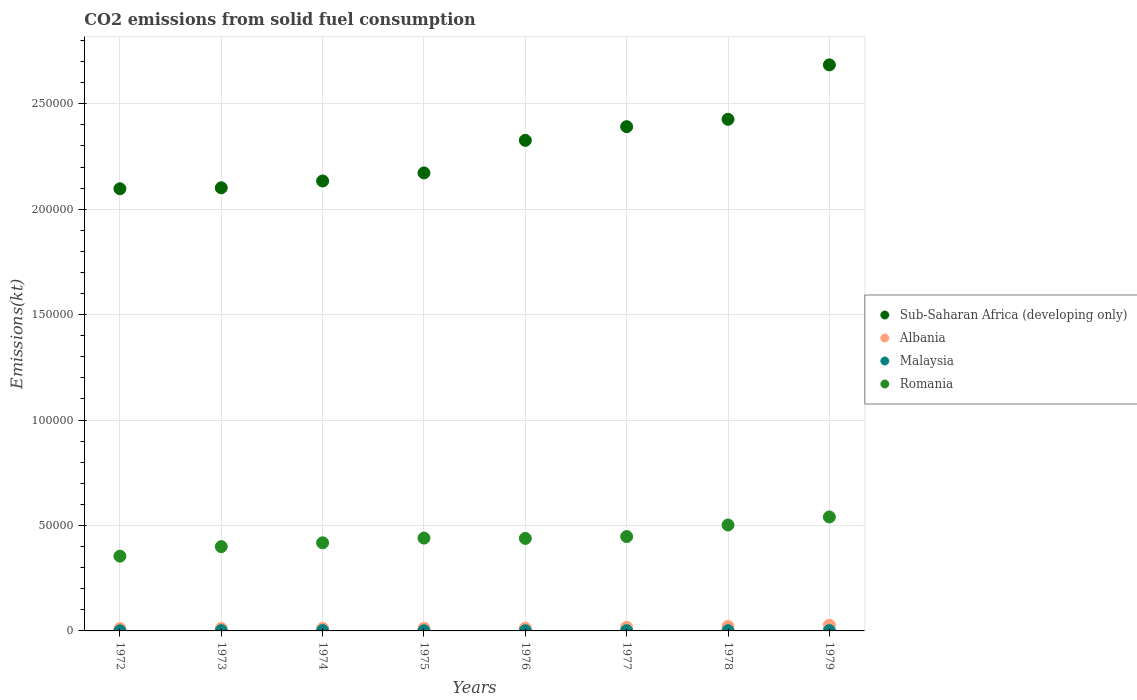What is the amount of CO2 emitted in Malaysia in 1976?
Your answer should be compact. 95.34. Across all years, what is the maximum amount of CO2 emitted in Malaysia?
Offer a very short reply. 161.35. Across all years, what is the minimum amount of CO2 emitted in Romania?
Provide a succinct answer. 3.55e+04. In which year was the amount of CO2 emitted in Malaysia maximum?
Offer a terse response. 1974. In which year was the amount of CO2 emitted in Romania minimum?
Offer a terse response. 1972. What is the total amount of CO2 emitted in Sub-Saharan Africa (developing only) in the graph?
Give a very brief answer. 1.83e+06. What is the difference between the amount of CO2 emitted in Malaysia in 1973 and that in 1979?
Your answer should be compact. -7.33. What is the difference between the amount of CO2 emitted in Sub-Saharan Africa (developing only) in 1973 and the amount of CO2 emitted in Albania in 1975?
Make the answer very short. 2.09e+05. What is the average amount of CO2 emitted in Malaysia per year?
Offer a terse response. 104.05. In the year 1975, what is the difference between the amount of CO2 emitted in Sub-Saharan Africa (developing only) and amount of CO2 emitted in Albania?
Your answer should be compact. 2.16e+05. In how many years, is the amount of CO2 emitted in Sub-Saharan Africa (developing only) greater than 40000 kt?
Keep it short and to the point. 8. What is the ratio of the amount of CO2 emitted in Malaysia in 1976 to that in 1977?
Give a very brief answer. 0.81. Is the amount of CO2 emitted in Sub-Saharan Africa (developing only) in 1973 less than that in 1975?
Offer a very short reply. Yes. Is the difference between the amount of CO2 emitted in Sub-Saharan Africa (developing only) in 1973 and 1974 greater than the difference between the amount of CO2 emitted in Albania in 1973 and 1974?
Provide a succinct answer. No. What is the difference between the highest and the second highest amount of CO2 emitted in Sub-Saharan Africa (developing only)?
Provide a short and direct response. 2.58e+04. What is the difference between the highest and the lowest amount of CO2 emitted in Sub-Saharan Africa (developing only)?
Keep it short and to the point. 5.87e+04. Is the sum of the amount of CO2 emitted in Albania in 1972 and 1978 greater than the maximum amount of CO2 emitted in Romania across all years?
Your answer should be very brief. No. Is the amount of CO2 emitted in Sub-Saharan Africa (developing only) strictly less than the amount of CO2 emitted in Albania over the years?
Provide a short and direct response. No. How many years are there in the graph?
Offer a terse response. 8. What is the difference between two consecutive major ticks on the Y-axis?
Offer a very short reply. 5.00e+04. Does the graph contain any zero values?
Give a very brief answer. No. Does the graph contain grids?
Your response must be concise. Yes. Where does the legend appear in the graph?
Make the answer very short. Center right. How many legend labels are there?
Give a very brief answer. 4. What is the title of the graph?
Give a very brief answer. CO2 emissions from solid fuel consumption. What is the label or title of the Y-axis?
Your answer should be very brief. Emissions(kt). What is the Emissions(kt) in Sub-Saharan Africa (developing only) in 1972?
Your answer should be very brief. 2.10e+05. What is the Emissions(kt) of Albania in 1972?
Your response must be concise. 1081.77. What is the Emissions(kt) in Malaysia in 1972?
Ensure brevity in your answer.  33. What is the Emissions(kt) of Romania in 1972?
Give a very brief answer. 3.55e+04. What is the Emissions(kt) of Sub-Saharan Africa (developing only) in 1973?
Give a very brief answer. 2.10e+05. What is the Emissions(kt) of Albania in 1973?
Your answer should be compact. 1169.77. What is the Emissions(kt) in Malaysia in 1973?
Provide a short and direct response. 128.34. What is the Emissions(kt) in Romania in 1973?
Offer a very short reply. 4.00e+04. What is the Emissions(kt) of Sub-Saharan Africa (developing only) in 1974?
Ensure brevity in your answer.  2.13e+05. What is the Emissions(kt) of Albania in 1974?
Your answer should be compact. 1210.11. What is the Emissions(kt) of Malaysia in 1974?
Offer a terse response. 161.35. What is the Emissions(kt) in Romania in 1974?
Your answer should be very brief. 4.18e+04. What is the Emissions(kt) of Sub-Saharan Africa (developing only) in 1975?
Give a very brief answer. 2.17e+05. What is the Emissions(kt) of Albania in 1975?
Make the answer very short. 1261.45. What is the Emissions(kt) of Malaysia in 1975?
Offer a very short reply. 69.67. What is the Emissions(kt) in Romania in 1975?
Your answer should be compact. 4.40e+04. What is the Emissions(kt) in Sub-Saharan Africa (developing only) in 1976?
Ensure brevity in your answer.  2.33e+05. What is the Emissions(kt) in Albania in 1976?
Your answer should be very brief. 1272.45. What is the Emissions(kt) in Malaysia in 1976?
Your answer should be compact. 95.34. What is the Emissions(kt) of Romania in 1976?
Your response must be concise. 4.39e+04. What is the Emissions(kt) in Sub-Saharan Africa (developing only) in 1977?
Ensure brevity in your answer.  2.39e+05. What is the Emissions(kt) in Albania in 1977?
Your answer should be very brief. 1701.49. What is the Emissions(kt) in Malaysia in 1977?
Make the answer very short. 117.34. What is the Emissions(kt) in Romania in 1977?
Provide a succinct answer. 4.47e+04. What is the Emissions(kt) in Sub-Saharan Africa (developing only) in 1978?
Provide a short and direct response. 2.43e+05. What is the Emissions(kt) of Albania in 1978?
Your answer should be very brief. 2126.86. What is the Emissions(kt) of Malaysia in 1978?
Your response must be concise. 91.67. What is the Emissions(kt) in Romania in 1978?
Your answer should be very brief. 5.02e+04. What is the Emissions(kt) in Sub-Saharan Africa (developing only) in 1979?
Your answer should be compact. 2.68e+05. What is the Emissions(kt) of Albania in 1979?
Your answer should be very brief. 2684.24. What is the Emissions(kt) in Malaysia in 1979?
Offer a terse response. 135.68. What is the Emissions(kt) in Romania in 1979?
Your answer should be compact. 5.40e+04. Across all years, what is the maximum Emissions(kt) in Sub-Saharan Africa (developing only)?
Offer a very short reply. 2.68e+05. Across all years, what is the maximum Emissions(kt) of Albania?
Make the answer very short. 2684.24. Across all years, what is the maximum Emissions(kt) in Malaysia?
Ensure brevity in your answer.  161.35. Across all years, what is the maximum Emissions(kt) in Romania?
Give a very brief answer. 5.40e+04. Across all years, what is the minimum Emissions(kt) of Sub-Saharan Africa (developing only)?
Give a very brief answer. 2.10e+05. Across all years, what is the minimum Emissions(kt) in Albania?
Offer a very short reply. 1081.77. Across all years, what is the minimum Emissions(kt) of Malaysia?
Offer a terse response. 33. Across all years, what is the minimum Emissions(kt) of Romania?
Your answer should be very brief. 3.55e+04. What is the total Emissions(kt) of Sub-Saharan Africa (developing only) in the graph?
Your response must be concise. 1.83e+06. What is the total Emissions(kt) of Albania in the graph?
Ensure brevity in your answer.  1.25e+04. What is the total Emissions(kt) in Malaysia in the graph?
Provide a short and direct response. 832.41. What is the total Emissions(kt) of Romania in the graph?
Ensure brevity in your answer.  3.54e+05. What is the difference between the Emissions(kt) of Sub-Saharan Africa (developing only) in 1972 and that in 1973?
Give a very brief answer. -464.89. What is the difference between the Emissions(kt) of Albania in 1972 and that in 1973?
Provide a short and direct response. -88.01. What is the difference between the Emissions(kt) of Malaysia in 1972 and that in 1973?
Keep it short and to the point. -95.34. What is the difference between the Emissions(kt) of Romania in 1972 and that in 1973?
Your answer should be very brief. -4517.74. What is the difference between the Emissions(kt) of Sub-Saharan Africa (developing only) in 1972 and that in 1974?
Keep it short and to the point. -3683.84. What is the difference between the Emissions(kt) in Albania in 1972 and that in 1974?
Give a very brief answer. -128.34. What is the difference between the Emissions(kt) of Malaysia in 1972 and that in 1974?
Provide a succinct answer. -128.34. What is the difference between the Emissions(kt) of Romania in 1972 and that in 1974?
Make the answer very short. -6340.24. What is the difference between the Emissions(kt) of Sub-Saharan Africa (developing only) in 1972 and that in 1975?
Provide a succinct answer. -7510.91. What is the difference between the Emissions(kt) of Albania in 1972 and that in 1975?
Offer a very short reply. -179.68. What is the difference between the Emissions(kt) of Malaysia in 1972 and that in 1975?
Make the answer very short. -36.67. What is the difference between the Emissions(kt) of Romania in 1972 and that in 1975?
Your answer should be very brief. -8573.45. What is the difference between the Emissions(kt) in Sub-Saharan Africa (developing only) in 1972 and that in 1976?
Your answer should be compact. -2.30e+04. What is the difference between the Emissions(kt) of Albania in 1972 and that in 1976?
Offer a terse response. -190.68. What is the difference between the Emissions(kt) of Malaysia in 1972 and that in 1976?
Provide a short and direct response. -62.34. What is the difference between the Emissions(kt) in Romania in 1972 and that in 1976?
Your answer should be very brief. -8419.43. What is the difference between the Emissions(kt) of Sub-Saharan Africa (developing only) in 1972 and that in 1977?
Give a very brief answer. -2.94e+04. What is the difference between the Emissions(kt) of Albania in 1972 and that in 1977?
Ensure brevity in your answer.  -619.72. What is the difference between the Emissions(kt) of Malaysia in 1972 and that in 1977?
Your answer should be very brief. -84.34. What is the difference between the Emissions(kt) of Romania in 1972 and that in 1977?
Ensure brevity in your answer.  -9295.84. What is the difference between the Emissions(kt) of Sub-Saharan Africa (developing only) in 1972 and that in 1978?
Offer a very short reply. -3.29e+04. What is the difference between the Emissions(kt) in Albania in 1972 and that in 1978?
Your answer should be very brief. -1045.1. What is the difference between the Emissions(kt) of Malaysia in 1972 and that in 1978?
Ensure brevity in your answer.  -58.67. What is the difference between the Emissions(kt) in Romania in 1972 and that in 1978?
Provide a short and direct response. -1.48e+04. What is the difference between the Emissions(kt) of Sub-Saharan Africa (developing only) in 1972 and that in 1979?
Keep it short and to the point. -5.87e+04. What is the difference between the Emissions(kt) of Albania in 1972 and that in 1979?
Offer a very short reply. -1602.48. What is the difference between the Emissions(kt) in Malaysia in 1972 and that in 1979?
Offer a terse response. -102.68. What is the difference between the Emissions(kt) of Romania in 1972 and that in 1979?
Your answer should be compact. -1.86e+04. What is the difference between the Emissions(kt) of Sub-Saharan Africa (developing only) in 1973 and that in 1974?
Ensure brevity in your answer.  -3218.95. What is the difference between the Emissions(kt) in Albania in 1973 and that in 1974?
Offer a terse response. -40.34. What is the difference between the Emissions(kt) in Malaysia in 1973 and that in 1974?
Provide a short and direct response. -33. What is the difference between the Emissions(kt) of Romania in 1973 and that in 1974?
Your response must be concise. -1822.5. What is the difference between the Emissions(kt) of Sub-Saharan Africa (developing only) in 1973 and that in 1975?
Offer a very short reply. -7046.02. What is the difference between the Emissions(kt) of Albania in 1973 and that in 1975?
Ensure brevity in your answer.  -91.67. What is the difference between the Emissions(kt) in Malaysia in 1973 and that in 1975?
Keep it short and to the point. 58.67. What is the difference between the Emissions(kt) in Romania in 1973 and that in 1975?
Make the answer very short. -4055.7. What is the difference between the Emissions(kt) in Sub-Saharan Africa (developing only) in 1973 and that in 1976?
Keep it short and to the point. -2.25e+04. What is the difference between the Emissions(kt) of Albania in 1973 and that in 1976?
Your answer should be very brief. -102.68. What is the difference between the Emissions(kt) in Malaysia in 1973 and that in 1976?
Ensure brevity in your answer.  33. What is the difference between the Emissions(kt) in Romania in 1973 and that in 1976?
Provide a short and direct response. -3901.69. What is the difference between the Emissions(kt) in Sub-Saharan Africa (developing only) in 1973 and that in 1977?
Make the answer very short. -2.90e+04. What is the difference between the Emissions(kt) of Albania in 1973 and that in 1977?
Offer a very short reply. -531.72. What is the difference between the Emissions(kt) of Malaysia in 1973 and that in 1977?
Provide a succinct answer. 11. What is the difference between the Emissions(kt) in Romania in 1973 and that in 1977?
Your answer should be compact. -4778.1. What is the difference between the Emissions(kt) of Sub-Saharan Africa (developing only) in 1973 and that in 1978?
Your answer should be very brief. -3.25e+04. What is the difference between the Emissions(kt) of Albania in 1973 and that in 1978?
Give a very brief answer. -957.09. What is the difference between the Emissions(kt) of Malaysia in 1973 and that in 1978?
Ensure brevity in your answer.  36.67. What is the difference between the Emissions(kt) of Romania in 1973 and that in 1978?
Give a very brief answer. -1.03e+04. What is the difference between the Emissions(kt) in Sub-Saharan Africa (developing only) in 1973 and that in 1979?
Give a very brief answer. -5.83e+04. What is the difference between the Emissions(kt) in Albania in 1973 and that in 1979?
Offer a very short reply. -1514.47. What is the difference between the Emissions(kt) of Malaysia in 1973 and that in 1979?
Give a very brief answer. -7.33. What is the difference between the Emissions(kt) of Romania in 1973 and that in 1979?
Offer a terse response. -1.41e+04. What is the difference between the Emissions(kt) of Sub-Saharan Africa (developing only) in 1974 and that in 1975?
Your answer should be compact. -3827.07. What is the difference between the Emissions(kt) in Albania in 1974 and that in 1975?
Make the answer very short. -51.34. What is the difference between the Emissions(kt) in Malaysia in 1974 and that in 1975?
Give a very brief answer. 91.67. What is the difference between the Emissions(kt) in Romania in 1974 and that in 1975?
Keep it short and to the point. -2233.2. What is the difference between the Emissions(kt) of Sub-Saharan Africa (developing only) in 1974 and that in 1976?
Keep it short and to the point. -1.93e+04. What is the difference between the Emissions(kt) of Albania in 1974 and that in 1976?
Provide a short and direct response. -62.34. What is the difference between the Emissions(kt) of Malaysia in 1974 and that in 1976?
Your response must be concise. 66.01. What is the difference between the Emissions(kt) of Romania in 1974 and that in 1976?
Offer a very short reply. -2079.19. What is the difference between the Emissions(kt) of Sub-Saharan Africa (developing only) in 1974 and that in 1977?
Provide a short and direct response. -2.58e+04. What is the difference between the Emissions(kt) in Albania in 1974 and that in 1977?
Provide a short and direct response. -491.38. What is the difference between the Emissions(kt) of Malaysia in 1974 and that in 1977?
Ensure brevity in your answer.  44. What is the difference between the Emissions(kt) in Romania in 1974 and that in 1977?
Your answer should be compact. -2955.6. What is the difference between the Emissions(kt) of Sub-Saharan Africa (developing only) in 1974 and that in 1978?
Provide a succinct answer. -2.93e+04. What is the difference between the Emissions(kt) of Albania in 1974 and that in 1978?
Offer a very short reply. -916.75. What is the difference between the Emissions(kt) of Malaysia in 1974 and that in 1978?
Keep it short and to the point. 69.67. What is the difference between the Emissions(kt) in Romania in 1974 and that in 1978?
Provide a short and direct response. -8441.43. What is the difference between the Emissions(kt) in Sub-Saharan Africa (developing only) in 1974 and that in 1979?
Ensure brevity in your answer.  -5.51e+04. What is the difference between the Emissions(kt) in Albania in 1974 and that in 1979?
Your answer should be compact. -1474.13. What is the difference between the Emissions(kt) of Malaysia in 1974 and that in 1979?
Offer a terse response. 25.67. What is the difference between the Emissions(kt) of Romania in 1974 and that in 1979?
Offer a terse response. -1.23e+04. What is the difference between the Emissions(kt) in Sub-Saharan Africa (developing only) in 1975 and that in 1976?
Your response must be concise. -1.54e+04. What is the difference between the Emissions(kt) in Albania in 1975 and that in 1976?
Ensure brevity in your answer.  -11. What is the difference between the Emissions(kt) in Malaysia in 1975 and that in 1976?
Make the answer very short. -25.67. What is the difference between the Emissions(kt) of Romania in 1975 and that in 1976?
Keep it short and to the point. 154.01. What is the difference between the Emissions(kt) of Sub-Saharan Africa (developing only) in 1975 and that in 1977?
Make the answer very short. -2.19e+04. What is the difference between the Emissions(kt) in Albania in 1975 and that in 1977?
Provide a succinct answer. -440.04. What is the difference between the Emissions(kt) of Malaysia in 1975 and that in 1977?
Your response must be concise. -47.67. What is the difference between the Emissions(kt) of Romania in 1975 and that in 1977?
Provide a short and direct response. -722.4. What is the difference between the Emissions(kt) of Sub-Saharan Africa (developing only) in 1975 and that in 1978?
Make the answer very short. -2.54e+04. What is the difference between the Emissions(kt) in Albania in 1975 and that in 1978?
Your response must be concise. -865.41. What is the difference between the Emissions(kt) in Malaysia in 1975 and that in 1978?
Give a very brief answer. -22. What is the difference between the Emissions(kt) of Romania in 1975 and that in 1978?
Offer a very short reply. -6208.23. What is the difference between the Emissions(kt) in Sub-Saharan Africa (developing only) in 1975 and that in 1979?
Offer a terse response. -5.12e+04. What is the difference between the Emissions(kt) in Albania in 1975 and that in 1979?
Provide a succinct answer. -1422.8. What is the difference between the Emissions(kt) of Malaysia in 1975 and that in 1979?
Your answer should be compact. -66.01. What is the difference between the Emissions(kt) in Romania in 1975 and that in 1979?
Your answer should be very brief. -1.00e+04. What is the difference between the Emissions(kt) of Sub-Saharan Africa (developing only) in 1976 and that in 1977?
Provide a short and direct response. -6484.05. What is the difference between the Emissions(kt) in Albania in 1976 and that in 1977?
Your response must be concise. -429.04. What is the difference between the Emissions(kt) of Malaysia in 1976 and that in 1977?
Keep it short and to the point. -22. What is the difference between the Emissions(kt) in Romania in 1976 and that in 1977?
Provide a short and direct response. -876.41. What is the difference between the Emissions(kt) in Sub-Saharan Africa (developing only) in 1976 and that in 1978?
Keep it short and to the point. -9984.11. What is the difference between the Emissions(kt) of Albania in 1976 and that in 1978?
Your answer should be very brief. -854.41. What is the difference between the Emissions(kt) of Malaysia in 1976 and that in 1978?
Ensure brevity in your answer.  3.67. What is the difference between the Emissions(kt) of Romania in 1976 and that in 1978?
Provide a short and direct response. -6362.24. What is the difference between the Emissions(kt) of Sub-Saharan Africa (developing only) in 1976 and that in 1979?
Your response must be concise. -3.58e+04. What is the difference between the Emissions(kt) of Albania in 1976 and that in 1979?
Ensure brevity in your answer.  -1411.8. What is the difference between the Emissions(kt) of Malaysia in 1976 and that in 1979?
Your answer should be very brief. -40.34. What is the difference between the Emissions(kt) of Romania in 1976 and that in 1979?
Give a very brief answer. -1.02e+04. What is the difference between the Emissions(kt) of Sub-Saharan Africa (developing only) in 1977 and that in 1978?
Your response must be concise. -3500.06. What is the difference between the Emissions(kt) in Albania in 1977 and that in 1978?
Your answer should be very brief. -425.37. What is the difference between the Emissions(kt) in Malaysia in 1977 and that in 1978?
Your response must be concise. 25.67. What is the difference between the Emissions(kt) of Romania in 1977 and that in 1978?
Provide a short and direct response. -5485.83. What is the difference between the Emissions(kt) of Sub-Saharan Africa (developing only) in 1977 and that in 1979?
Your response must be concise. -2.93e+04. What is the difference between the Emissions(kt) in Albania in 1977 and that in 1979?
Ensure brevity in your answer.  -982.76. What is the difference between the Emissions(kt) of Malaysia in 1977 and that in 1979?
Offer a very short reply. -18.34. What is the difference between the Emissions(kt) in Romania in 1977 and that in 1979?
Your answer should be compact. -9295.84. What is the difference between the Emissions(kt) in Sub-Saharan Africa (developing only) in 1978 and that in 1979?
Give a very brief answer. -2.58e+04. What is the difference between the Emissions(kt) in Albania in 1978 and that in 1979?
Keep it short and to the point. -557.38. What is the difference between the Emissions(kt) in Malaysia in 1978 and that in 1979?
Provide a succinct answer. -44. What is the difference between the Emissions(kt) in Romania in 1978 and that in 1979?
Provide a short and direct response. -3810.01. What is the difference between the Emissions(kt) of Sub-Saharan Africa (developing only) in 1972 and the Emissions(kt) of Albania in 1973?
Your response must be concise. 2.09e+05. What is the difference between the Emissions(kt) in Sub-Saharan Africa (developing only) in 1972 and the Emissions(kt) in Malaysia in 1973?
Offer a very short reply. 2.10e+05. What is the difference between the Emissions(kt) of Sub-Saharan Africa (developing only) in 1972 and the Emissions(kt) of Romania in 1973?
Make the answer very short. 1.70e+05. What is the difference between the Emissions(kt) of Albania in 1972 and the Emissions(kt) of Malaysia in 1973?
Keep it short and to the point. 953.42. What is the difference between the Emissions(kt) of Albania in 1972 and the Emissions(kt) of Romania in 1973?
Keep it short and to the point. -3.89e+04. What is the difference between the Emissions(kt) of Malaysia in 1972 and the Emissions(kt) of Romania in 1973?
Make the answer very short. -3.99e+04. What is the difference between the Emissions(kt) in Sub-Saharan Africa (developing only) in 1972 and the Emissions(kt) in Albania in 1974?
Keep it short and to the point. 2.08e+05. What is the difference between the Emissions(kt) in Sub-Saharan Africa (developing only) in 1972 and the Emissions(kt) in Malaysia in 1974?
Give a very brief answer. 2.10e+05. What is the difference between the Emissions(kt) of Sub-Saharan Africa (developing only) in 1972 and the Emissions(kt) of Romania in 1974?
Your answer should be very brief. 1.68e+05. What is the difference between the Emissions(kt) of Albania in 1972 and the Emissions(kt) of Malaysia in 1974?
Give a very brief answer. 920.42. What is the difference between the Emissions(kt) of Albania in 1972 and the Emissions(kt) of Romania in 1974?
Give a very brief answer. -4.07e+04. What is the difference between the Emissions(kt) in Malaysia in 1972 and the Emissions(kt) in Romania in 1974?
Your answer should be very brief. -4.18e+04. What is the difference between the Emissions(kt) of Sub-Saharan Africa (developing only) in 1972 and the Emissions(kt) of Albania in 1975?
Your answer should be compact. 2.08e+05. What is the difference between the Emissions(kt) of Sub-Saharan Africa (developing only) in 1972 and the Emissions(kt) of Malaysia in 1975?
Ensure brevity in your answer.  2.10e+05. What is the difference between the Emissions(kt) of Sub-Saharan Africa (developing only) in 1972 and the Emissions(kt) of Romania in 1975?
Your response must be concise. 1.66e+05. What is the difference between the Emissions(kt) of Albania in 1972 and the Emissions(kt) of Malaysia in 1975?
Offer a terse response. 1012.09. What is the difference between the Emissions(kt) of Albania in 1972 and the Emissions(kt) of Romania in 1975?
Your answer should be very brief. -4.29e+04. What is the difference between the Emissions(kt) of Malaysia in 1972 and the Emissions(kt) of Romania in 1975?
Make the answer very short. -4.40e+04. What is the difference between the Emissions(kt) in Sub-Saharan Africa (developing only) in 1972 and the Emissions(kt) in Albania in 1976?
Your answer should be compact. 2.08e+05. What is the difference between the Emissions(kt) of Sub-Saharan Africa (developing only) in 1972 and the Emissions(kt) of Malaysia in 1976?
Offer a very short reply. 2.10e+05. What is the difference between the Emissions(kt) of Sub-Saharan Africa (developing only) in 1972 and the Emissions(kt) of Romania in 1976?
Make the answer very short. 1.66e+05. What is the difference between the Emissions(kt) in Albania in 1972 and the Emissions(kt) in Malaysia in 1976?
Give a very brief answer. 986.42. What is the difference between the Emissions(kt) of Albania in 1972 and the Emissions(kt) of Romania in 1976?
Offer a very short reply. -4.28e+04. What is the difference between the Emissions(kt) in Malaysia in 1972 and the Emissions(kt) in Romania in 1976?
Provide a short and direct response. -4.38e+04. What is the difference between the Emissions(kt) of Sub-Saharan Africa (developing only) in 1972 and the Emissions(kt) of Albania in 1977?
Keep it short and to the point. 2.08e+05. What is the difference between the Emissions(kt) in Sub-Saharan Africa (developing only) in 1972 and the Emissions(kt) in Malaysia in 1977?
Your response must be concise. 2.10e+05. What is the difference between the Emissions(kt) of Sub-Saharan Africa (developing only) in 1972 and the Emissions(kt) of Romania in 1977?
Offer a terse response. 1.65e+05. What is the difference between the Emissions(kt) in Albania in 1972 and the Emissions(kt) in Malaysia in 1977?
Make the answer very short. 964.42. What is the difference between the Emissions(kt) in Albania in 1972 and the Emissions(kt) in Romania in 1977?
Offer a very short reply. -4.37e+04. What is the difference between the Emissions(kt) in Malaysia in 1972 and the Emissions(kt) in Romania in 1977?
Your response must be concise. -4.47e+04. What is the difference between the Emissions(kt) in Sub-Saharan Africa (developing only) in 1972 and the Emissions(kt) in Albania in 1978?
Ensure brevity in your answer.  2.08e+05. What is the difference between the Emissions(kt) in Sub-Saharan Africa (developing only) in 1972 and the Emissions(kt) in Malaysia in 1978?
Keep it short and to the point. 2.10e+05. What is the difference between the Emissions(kt) in Sub-Saharan Africa (developing only) in 1972 and the Emissions(kt) in Romania in 1978?
Offer a very short reply. 1.59e+05. What is the difference between the Emissions(kt) in Albania in 1972 and the Emissions(kt) in Malaysia in 1978?
Offer a very short reply. 990.09. What is the difference between the Emissions(kt) of Albania in 1972 and the Emissions(kt) of Romania in 1978?
Provide a short and direct response. -4.92e+04. What is the difference between the Emissions(kt) of Malaysia in 1972 and the Emissions(kt) of Romania in 1978?
Make the answer very short. -5.02e+04. What is the difference between the Emissions(kt) in Sub-Saharan Africa (developing only) in 1972 and the Emissions(kt) in Albania in 1979?
Your response must be concise. 2.07e+05. What is the difference between the Emissions(kt) in Sub-Saharan Africa (developing only) in 1972 and the Emissions(kt) in Malaysia in 1979?
Your answer should be very brief. 2.10e+05. What is the difference between the Emissions(kt) of Sub-Saharan Africa (developing only) in 1972 and the Emissions(kt) of Romania in 1979?
Provide a short and direct response. 1.56e+05. What is the difference between the Emissions(kt) of Albania in 1972 and the Emissions(kt) of Malaysia in 1979?
Your response must be concise. 946.09. What is the difference between the Emissions(kt) of Albania in 1972 and the Emissions(kt) of Romania in 1979?
Offer a terse response. -5.30e+04. What is the difference between the Emissions(kt) of Malaysia in 1972 and the Emissions(kt) of Romania in 1979?
Keep it short and to the point. -5.40e+04. What is the difference between the Emissions(kt) of Sub-Saharan Africa (developing only) in 1973 and the Emissions(kt) of Albania in 1974?
Keep it short and to the point. 2.09e+05. What is the difference between the Emissions(kt) of Sub-Saharan Africa (developing only) in 1973 and the Emissions(kt) of Malaysia in 1974?
Your answer should be very brief. 2.10e+05. What is the difference between the Emissions(kt) of Sub-Saharan Africa (developing only) in 1973 and the Emissions(kt) of Romania in 1974?
Offer a very short reply. 1.68e+05. What is the difference between the Emissions(kt) of Albania in 1973 and the Emissions(kt) of Malaysia in 1974?
Keep it short and to the point. 1008.42. What is the difference between the Emissions(kt) in Albania in 1973 and the Emissions(kt) in Romania in 1974?
Your response must be concise. -4.06e+04. What is the difference between the Emissions(kt) in Malaysia in 1973 and the Emissions(kt) in Romania in 1974?
Keep it short and to the point. -4.17e+04. What is the difference between the Emissions(kt) of Sub-Saharan Africa (developing only) in 1973 and the Emissions(kt) of Albania in 1975?
Provide a succinct answer. 2.09e+05. What is the difference between the Emissions(kt) in Sub-Saharan Africa (developing only) in 1973 and the Emissions(kt) in Malaysia in 1975?
Your response must be concise. 2.10e+05. What is the difference between the Emissions(kt) of Sub-Saharan Africa (developing only) in 1973 and the Emissions(kt) of Romania in 1975?
Provide a short and direct response. 1.66e+05. What is the difference between the Emissions(kt) of Albania in 1973 and the Emissions(kt) of Malaysia in 1975?
Offer a terse response. 1100.1. What is the difference between the Emissions(kt) in Albania in 1973 and the Emissions(kt) in Romania in 1975?
Make the answer very short. -4.29e+04. What is the difference between the Emissions(kt) in Malaysia in 1973 and the Emissions(kt) in Romania in 1975?
Provide a short and direct response. -4.39e+04. What is the difference between the Emissions(kt) of Sub-Saharan Africa (developing only) in 1973 and the Emissions(kt) of Albania in 1976?
Your answer should be very brief. 2.09e+05. What is the difference between the Emissions(kt) of Sub-Saharan Africa (developing only) in 1973 and the Emissions(kt) of Malaysia in 1976?
Ensure brevity in your answer.  2.10e+05. What is the difference between the Emissions(kt) in Sub-Saharan Africa (developing only) in 1973 and the Emissions(kt) in Romania in 1976?
Offer a terse response. 1.66e+05. What is the difference between the Emissions(kt) of Albania in 1973 and the Emissions(kt) of Malaysia in 1976?
Provide a succinct answer. 1074.43. What is the difference between the Emissions(kt) in Albania in 1973 and the Emissions(kt) in Romania in 1976?
Your answer should be very brief. -4.27e+04. What is the difference between the Emissions(kt) in Malaysia in 1973 and the Emissions(kt) in Romania in 1976?
Provide a succinct answer. -4.37e+04. What is the difference between the Emissions(kt) in Sub-Saharan Africa (developing only) in 1973 and the Emissions(kt) in Albania in 1977?
Provide a short and direct response. 2.08e+05. What is the difference between the Emissions(kt) of Sub-Saharan Africa (developing only) in 1973 and the Emissions(kt) of Malaysia in 1977?
Keep it short and to the point. 2.10e+05. What is the difference between the Emissions(kt) of Sub-Saharan Africa (developing only) in 1973 and the Emissions(kt) of Romania in 1977?
Your response must be concise. 1.65e+05. What is the difference between the Emissions(kt) of Albania in 1973 and the Emissions(kt) of Malaysia in 1977?
Your response must be concise. 1052.43. What is the difference between the Emissions(kt) of Albania in 1973 and the Emissions(kt) of Romania in 1977?
Make the answer very short. -4.36e+04. What is the difference between the Emissions(kt) of Malaysia in 1973 and the Emissions(kt) of Romania in 1977?
Keep it short and to the point. -4.46e+04. What is the difference between the Emissions(kt) of Sub-Saharan Africa (developing only) in 1973 and the Emissions(kt) of Albania in 1978?
Keep it short and to the point. 2.08e+05. What is the difference between the Emissions(kt) in Sub-Saharan Africa (developing only) in 1973 and the Emissions(kt) in Malaysia in 1978?
Provide a short and direct response. 2.10e+05. What is the difference between the Emissions(kt) in Sub-Saharan Africa (developing only) in 1973 and the Emissions(kt) in Romania in 1978?
Your answer should be very brief. 1.60e+05. What is the difference between the Emissions(kt) in Albania in 1973 and the Emissions(kt) in Malaysia in 1978?
Give a very brief answer. 1078.1. What is the difference between the Emissions(kt) of Albania in 1973 and the Emissions(kt) of Romania in 1978?
Provide a succinct answer. -4.91e+04. What is the difference between the Emissions(kt) in Malaysia in 1973 and the Emissions(kt) in Romania in 1978?
Provide a succinct answer. -5.01e+04. What is the difference between the Emissions(kt) of Sub-Saharan Africa (developing only) in 1973 and the Emissions(kt) of Albania in 1979?
Your answer should be compact. 2.07e+05. What is the difference between the Emissions(kt) of Sub-Saharan Africa (developing only) in 1973 and the Emissions(kt) of Malaysia in 1979?
Your answer should be very brief. 2.10e+05. What is the difference between the Emissions(kt) in Sub-Saharan Africa (developing only) in 1973 and the Emissions(kt) in Romania in 1979?
Offer a very short reply. 1.56e+05. What is the difference between the Emissions(kt) of Albania in 1973 and the Emissions(kt) of Malaysia in 1979?
Your answer should be compact. 1034.09. What is the difference between the Emissions(kt) in Albania in 1973 and the Emissions(kt) in Romania in 1979?
Give a very brief answer. -5.29e+04. What is the difference between the Emissions(kt) in Malaysia in 1973 and the Emissions(kt) in Romania in 1979?
Your answer should be compact. -5.39e+04. What is the difference between the Emissions(kt) of Sub-Saharan Africa (developing only) in 1974 and the Emissions(kt) of Albania in 1975?
Your answer should be very brief. 2.12e+05. What is the difference between the Emissions(kt) of Sub-Saharan Africa (developing only) in 1974 and the Emissions(kt) of Malaysia in 1975?
Provide a short and direct response. 2.13e+05. What is the difference between the Emissions(kt) in Sub-Saharan Africa (developing only) in 1974 and the Emissions(kt) in Romania in 1975?
Offer a very short reply. 1.69e+05. What is the difference between the Emissions(kt) of Albania in 1974 and the Emissions(kt) of Malaysia in 1975?
Ensure brevity in your answer.  1140.44. What is the difference between the Emissions(kt) in Albania in 1974 and the Emissions(kt) in Romania in 1975?
Provide a succinct answer. -4.28e+04. What is the difference between the Emissions(kt) in Malaysia in 1974 and the Emissions(kt) in Romania in 1975?
Your answer should be very brief. -4.39e+04. What is the difference between the Emissions(kt) in Sub-Saharan Africa (developing only) in 1974 and the Emissions(kt) in Albania in 1976?
Keep it short and to the point. 2.12e+05. What is the difference between the Emissions(kt) of Sub-Saharan Africa (developing only) in 1974 and the Emissions(kt) of Malaysia in 1976?
Provide a short and direct response. 2.13e+05. What is the difference between the Emissions(kt) in Sub-Saharan Africa (developing only) in 1974 and the Emissions(kt) in Romania in 1976?
Give a very brief answer. 1.70e+05. What is the difference between the Emissions(kt) in Albania in 1974 and the Emissions(kt) in Malaysia in 1976?
Ensure brevity in your answer.  1114.77. What is the difference between the Emissions(kt) in Albania in 1974 and the Emissions(kt) in Romania in 1976?
Your answer should be compact. -4.27e+04. What is the difference between the Emissions(kt) in Malaysia in 1974 and the Emissions(kt) in Romania in 1976?
Provide a succinct answer. -4.37e+04. What is the difference between the Emissions(kt) of Sub-Saharan Africa (developing only) in 1974 and the Emissions(kt) of Albania in 1977?
Provide a succinct answer. 2.12e+05. What is the difference between the Emissions(kt) of Sub-Saharan Africa (developing only) in 1974 and the Emissions(kt) of Malaysia in 1977?
Offer a terse response. 2.13e+05. What is the difference between the Emissions(kt) in Sub-Saharan Africa (developing only) in 1974 and the Emissions(kt) in Romania in 1977?
Your answer should be compact. 1.69e+05. What is the difference between the Emissions(kt) of Albania in 1974 and the Emissions(kt) of Malaysia in 1977?
Your answer should be very brief. 1092.77. What is the difference between the Emissions(kt) in Albania in 1974 and the Emissions(kt) in Romania in 1977?
Keep it short and to the point. -4.35e+04. What is the difference between the Emissions(kt) in Malaysia in 1974 and the Emissions(kt) in Romania in 1977?
Provide a succinct answer. -4.46e+04. What is the difference between the Emissions(kt) in Sub-Saharan Africa (developing only) in 1974 and the Emissions(kt) in Albania in 1978?
Offer a terse response. 2.11e+05. What is the difference between the Emissions(kt) in Sub-Saharan Africa (developing only) in 1974 and the Emissions(kt) in Malaysia in 1978?
Your answer should be compact. 2.13e+05. What is the difference between the Emissions(kt) of Sub-Saharan Africa (developing only) in 1974 and the Emissions(kt) of Romania in 1978?
Your answer should be very brief. 1.63e+05. What is the difference between the Emissions(kt) in Albania in 1974 and the Emissions(kt) in Malaysia in 1978?
Keep it short and to the point. 1118.43. What is the difference between the Emissions(kt) of Albania in 1974 and the Emissions(kt) of Romania in 1978?
Make the answer very short. -4.90e+04. What is the difference between the Emissions(kt) of Malaysia in 1974 and the Emissions(kt) of Romania in 1978?
Give a very brief answer. -5.01e+04. What is the difference between the Emissions(kt) in Sub-Saharan Africa (developing only) in 1974 and the Emissions(kt) in Albania in 1979?
Your response must be concise. 2.11e+05. What is the difference between the Emissions(kt) in Sub-Saharan Africa (developing only) in 1974 and the Emissions(kt) in Malaysia in 1979?
Your answer should be compact. 2.13e+05. What is the difference between the Emissions(kt) in Sub-Saharan Africa (developing only) in 1974 and the Emissions(kt) in Romania in 1979?
Keep it short and to the point. 1.59e+05. What is the difference between the Emissions(kt) in Albania in 1974 and the Emissions(kt) in Malaysia in 1979?
Your answer should be very brief. 1074.43. What is the difference between the Emissions(kt) of Albania in 1974 and the Emissions(kt) of Romania in 1979?
Your answer should be compact. -5.28e+04. What is the difference between the Emissions(kt) of Malaysia in 1974 and the Emissions(kt) of Romania in 1979?
Keep it short and to the point. -5.39e+04. What is the difference between the Emissions(kt) in Sub-Saharan Africa (developing only) in 1975 and the Emissions(kt) in Albania in 1976?
Make the answer very short. 2.16e+05. What is the difference between the Emissions(kt) of Sub-Saharan Africa (developing only) in 1975 and the Emissions(kt) of Malaysia in 1976?
Make the answer very short. 2.17e+05. What is the difference between the Emissions(kt) of Sub-Saharan Africa (developing only) in 1975 and the Emissions(kt) of Romania in 1976?
Provide a short and direct response. 1.73e+05. What is the difference between the Emissions(kt) in Albania in 1975 and the Emissions(kt) in Malaysia in 1976?
Give a very brief answer. 1166.11. What is the difference between the Emissions(kt) in Albania in 1975 and the Emissions(kt) in Romania in 1976?
Offer a very short reply. -4.26e+04. What is the difference between the Emissions(kt) in Malaysia in 1975 and the Emissions(kt) in Romania in 1976?
Offer a very short reply. -4.38e+04. What is the difference between the Emissions(kt) of Sub-Saharan Africa (developing only) in 1975 and the Emissions(kt) of Albania in 1977?
Your answer should be very brief. 2.16e+05. What is the difference between the Emissions(kt) of Sub-Saharan Africa (developing only) in 1975 and the Emissions(kt) of Malaysia in 1977?
Provide a short and direct response. 2.17e+05. What is the difference between the Emissions(kt) in Sub-Saharan Africa (developing only) in 1975 and the Emissions(kt) in Romania in 1977?
Make the answer very short. 1.72e+05. What is the difference between the Emissions(kt) of Albania in 1975 and the Emissions(kt) of Malaysia in 1977?
Provide a short and direct response. 1144.1. What is the difference between the Emissions(kt) in Albania in 1975 and the Emissions(kt) in Romania in 1977?
Provide a succinct answer. -4.35e+04. What is the difference between the Emissions(kt) in Malaysia in 1975 and the Emissions(kt) in Romania in 1977?
Offer a terse response. -4.47e+04. What is the difference between the Emissions(kt) of Sub-Saharan Africa (developing only) in 1975 and the Emissions(kt) of Albania in 1978?
Make the answer very short. 2.15e+05. What is the difference between the Emissions(kt) in Sub-Saharan Africa (developing only) in 1975 and the Emissions(kt) in Malaysia in 1978?
Your answer should be very brief. 2.17e+05. What is the difference between the Emissions(kt) in Sub-Saharan Africa (developing only) in 1975 and the Emissions(kt) in Romania in 1978?
Make the answer very short. 1.67e+05. What is the difference between the Emissions(kt) of Albania in 1975 and the Emissions(kt) of Malaysia in 1978?
Your answer should be very brief. 1169.77. What is the difference between the Emissions(kt) of Albania in 1975 and the Emissions(kt) of Romania in 1978?
Keep it short and to the point. -4.90e+04. What is the difference between the Emissions(kt) of Malaysia in 1975 and the Emissions(kt) of Romania in 1978?
Make the answer very short. -5.02e+04. What is the difference between the Emissions(kt) of Sub-Saharan Africa (developing only) in 1975 and the Emissions(kt) of Albania in 1979?
Offer a terse response. 2.15e+05. What is the difference between the Emissions(kt) of Sub-Saharan Africa (developing only) in 1975 and the Emissions(kt) of Malaysia in 1979?
Provide a succinct answer. 2.17e+05. What is the difference between the Emissions(kt) in Sub-Saharan Africa (developing only) in 1975 and the Emissions(kt) in Romania in 1979?
Your response must be concise. 1.63e+05. What is the difference between the Emissions(kt) in Albania in 1975 and the Emissions(kt) in Malaysia in 1979?
Give a very brief answer. 1125.77. What is the difference between the Emissions(kt) of Albania in 1975 and the Emissions(kt) of Romania in 1979?
Keep it short and to the point. -5.28e+04. What is the difference between the Emissions(kt) in Malaysia in 1975 and the Emissions(kt) in Romania in 1979?
Ensure brevity in your answer.  -5.40e+04. What is the difference between the Emissions(kt) of Sub-Saharan Africa (developing only) in 1976 and the Emissions(kt) of Albania in 1977?
Provide a succinct answer. 2.31e+05. What is the difference between the Emissions(kt) in Sub-Saharan Africa (developing only) in 1976 and the Emissions(kt) in Malaysia in 1977?
Your answer should be compact. 2.33e+05. What is the difference between the Emissions(kt) in Sub-Saharan Africa (developing only) in 1976 and the Emissions(kt) in Romania in 1977?
Provide a short and direct response. 1.88e+05. What is the difference between the Emissions(kt) in Albania in 1976 and the Emissions(kt) in Malaysia in 1977?
Provide a succinct answer. 1155.11. What is the difference between the Emissions(kt) in Albania in 1976 and the Emissions(kt) in Romania in 1977?
Provide a short and direct response. -4.35e+04. What is the difference between the Emissions(kt) of Malaysia in 1976 and the Emissions(kt) of Romania in 1977?
Provide a short and direct response. -4.47e+04. What is the difference between the Emissions(kt) of Sub-Saharan Africa (developing only) in 1976 and the Emissions(kt) of Albania in 1978?
Keep it short and to the point. 2.31e+05. What is the difference between the Emissions(kt) of Sub-Saharan Africa (developing only) in 1976 and the Emissions(kt) of Malaysia in 1978?
Your answer should be very brief. 2.33e+05. What is the difference between the Emissions(kt) of Sub-Saharan Africa (developing only) in 1976 and the Emissions(kt) of Romania in 1978?
Your answer should be very brief. 1.82e+05. What is the difference between the Emissions(kt) of Albania in 1976 and the Emissions(kt) of Malaysia in 1978?
Give a very brief answer. 1180.77. What is the difference between the Emissions(kt) of Albania in 1976 and the Emissions(kt) of Romania in 1978?
Your answer should be compact. -4.90e+04. What is the difference between the Emissions(kt) of Malaysia in 1976 and the Emissions(kt) of Romania in 1978?
Make the answer very short. -5.01e+04. What is the difference between the Emissions(kt) of Sub-Saharan Africa (developing only) in 1976 and the Emissions(kt) of Albania in 1979?
Ensure brevity in your answer.  2.30e+05. What is the difference between the Emissions(kt) in Sub-Saharan Africa (developing only) in 1976 and the Emissions(kt) in Malaysia in 1979?
Your answer should be very brief. 2.33e+05. What is the difference between the Emissions(kt) of Sub-Saharan Africa (developing only) in 1976 and the Emissions(kt) of Romania in 1979?
Provide a succinct answer. 1.79e+05. What is the difference between the Emissions(kt) in Albania in 1976 and the Emissions(kt) in Malaysia in 1979?
Offer a terse response. 1136.77. What is the difference between the Emissions(kt) in Albania in 1976 and the Emissions(kt) in Romania in 1979?
Keep it short and to the point. -5.28e+04. What is the difference between the Emissions(kt) of Malaysia in 1976 and the Emissions(kt) of Romania in 1979?
Offer a very short reply. -5.39e+04. What is the difference between the Emissions(kt) of Sub-Saharan Africa (developing only) in 1977 and the Emissions(kt) of Albania in 1978?
Keep it short and to the point. 2.37e+05. What is the difference between the Emissions(kt) of Sub-Saharan Africa (developing only) in 1977 and the Emissions(kt) of Malaysia in 1978?
Your answer should be compact. 2.39e+05. What is the difference between the Emissions(kt) of Sub-Saharan Africa (developing only) in 1977 and the Emissions(kt) of Romania in 1978?
Make the answer very short. 1.89e+05. What is the difference between the Emissions(kt) of Albania in 1977 and the Emissions(kt) of Malaysia in 1978?
Ensure brevity in your answer.  1609.81. What is the difference between the Emissions(kt) in Albania in 1977 and the Emissions(kt) in Romania in 1978?
Make the answer very short. -4.85e+04. What is the difference between the Emissions(kt) of Malaysia in 1977 and the Emissions(kt) of Romania in 1978?
Give a very brief answer. -5.01e+04. What is the difference between the Emissions(kt) in Sub-Saharan Africa (developing only) in 1977 and the Emissions(kt) in Albania in 1979?
Offer a very short reply. 2.36e+05. What is the difference between the Emissions(kt) of Sub-Saharan Africa (developing only) in 1977 and the Emissions(kt) of Malaysia in 1979?
Make the answer very short. 2.39e+05. What is the difference between the Emissions(kt) in Sub-Saharan Africa (developing only) in 1977 and the Emissions(kt) in Romania in 1979?
Your answer should be very brief. 1.85e+05. What is the difference between the Emissions(kt) in Albania in 1977 and the Emissions(kt) in Malaysia in 1979?
Your response must be concise. 1565.81. What is the difference between the Emissions(kt) in Albania in 1977 and the Emissions(kt) in Romania in 1979?
Your answer should be compact. -5.23e+04. What is the difference between the Emissions(kt) of Malaysia in 1977 and the Emissions(kt) of Romania in 1979?
Offer a terse response. -5.39e+04. What is the difference between the Emissions(kt) in Sub-Saharan Africa (developing only) in 1978 and the Emissions(kt) in Albania in 1979?
Your response must be concise. 2.40e+05. What is the difference between the Emissions(kt) in Sub-Saharan Africa (developing only) in 1978 and the Emissions(kt) in Malaysia in 1979?
Provide a short and direct response. 2.43e+05. What is the difference between the Emissions(kt) in Sub-Saharan Africa (developing only) in 1978 and the Emissions(kt) in Romania in 1979?
Offer a very short reply. 1.89e+05. What is the difference between the Emissions(kt) in Albania in 1978 and the Emissions(kt) in Malaysia in 1979?
Offer a terse response. 1991.18. What is the difference between the Emissions(kt) of Albania in 1978 and the Emissions(kt) of Romania in 1979?
Give a very brief answer. -5.19e+04. What is the difference between the Emissions(kt) of Malaysia in 1978 and the Emissions(kt) of Romania in 1979?
Make the answer very short. -5.40e+04. What is the average Emissions(kt) of Sub-Saharan Africa (developing only) per year?
Provide a short and direct response. 2.29e+05. What is the average Emissions(kt) of Albania per year?
Provide a succinct answer. 1563.52. What is the average Emissions(kt) in Malaysia per year?
Your answer should be very brief. 104.05. What is the average Emissions(kt) of Romania per year?
Your answer should be compact. 4.43e+04. In the year 1972, what is the difference between the Emissions(kt) of Sub-Saharan Africa (developing only) and Emissions(kt) of Albania?
Offer a terse response. 2.09e+05. In the year 1972, what is the difference between the Emissions(kt) of Sub-Saharan Africa (developing only) and Emissions(kt) of Malaysia?
Your response must be concise. 2.10e+05. In the year 1972, what is the difference between the Emissions(kt) in Sub-Saharan Africa (developing only) and Emissions(kt) in Romania?
Provide a short and direct response. 1.74e+05. In the year 1972, what is the difference between the Emissions(kt) in Albania and Emissions(kt) in Malaysia?
Ensure brevity in your answer.  1048.76. In the year 1972, what is the difference between the Emissions(kt) in Albania and Emissions(kt) in Romania?
Ensure brevity in your answer.  -3.44e+04. In the year 1972, what is the difference between the Emissions(kt) of Malaysia and Emissions(kt) of Romania?
Provide a short and direct response. -3.54e+04. In the year 1973, what is the difference between the Emissions(kt) in Sub-Saharan Africa (developing only) and Emissions(kt) in Albania?
Make the answer very short. 2.09e+05. In the year 1973, what is the difference between the Emissions(kt) in Sub-Saharan Africa (developing only) and Emissions(kt) in Malaysia?
Your response must be concise. 2.10e+05. In the year 1973, what is the difference between the Emissions(kt) in Sub-Saharan Africa (developing only) and Emissions(kt) in Romania?
Your answer should be compact. 1.70e+05. In the year 1973, what is the difference between the Emissions(kt) in Albania and Emissions(kt) in Malaysia?
Provide a succinct answer. 1041.43. In the year 1973, what is the difference between the Emissions(kt) of Albania and Emissions(kt) of Romania?
Your answer should be very brief. -3.88e+04. In the year 1973, what is the difference between the Emissions(kt) in Malaysia and Emissions(kt) in Romania?
Provide a short and direct response. -3.98e+04. In the year 1974, what is the difference between the Emissions(kt) of Sub-Saharan Africa (developing only) and Emissions(kt) of Albania?
Give a very brief answer. 2.12e+05. In the year 1974, what is the difference between the Emissions(kt) of Sub-Saharan Africa (developing only) and Emissions(kt) of Malaysia?
Offer a very short reply. 2.13e+05. In the year 1974, what is the difference between the Emissions(kt) of Sub-Saharan Africa (developing only) and Emissions(kt) of Romania?
Your answer should be compact. 1.72e+05. In the year 1974, what is the difference between the Emissions(kt) in Albania and Emissions(kt) in Malaysia?
Keep it short and to the point. 1048.76. In the year 1974, what is the difference between the Emissions(kt) of Albania and Emissions(kt) of Romania?
Give a very brief answer. -4.06e+04. In the year 1974, what is the difference between the Emissions(kt) of Malaysia and Emissions(kt) of Romania?
Your answer should be very brief. -4.16e+04. In the year 1975, what is the difference between the Emissions(kt) of Sub-Saharan Africa (developing only) and Emissions(kt) of Albania?
Make the answer very short. 2.16e+05. In the year 1975, what is the difference between the Emissions(kt) of Sub-Saharan Africa (developing only) and Emissions(kt) of Malaysia?
Give a very brief answer. 2.17e+05. In the year 1975, what is the difference between the Emissions(kt) of Sub-Saharan Africa (developing only) and Emissions(kt) of Romania?
Provide a short and direct response. 1.73e+05. In the year 1975, what is the difference between the Emissions(kt) in Albania and Emissions(kt) in Malaysia?
Ensure brevity in your answer.  1191.78. In the year 1975, what is the difference between the Emissions(kt) of Albania and Emissions(kt) of Romania?
Your answer should be compact. -4.28e+04. In the year 1975, what is the difference between the Emissions(kt) in Malaysia and Emissions(kt) in Romania?
Your answer should be compact. -4.40e+04. In the year 1976, what is the difference between the Emissions(kt) of Sub-Saharan Africa (developing only) and Emissions(kt) of Albania?
Ensure brevity in your answer.  2.31e+05. In the year 1976, what is the difference between the Emissions(kt) in Sub-Saharan Africa (developing only) and Emissions(kt) in Malaysia?
Your answer should be compact. 2.33e+05. In the year 1976, what is the difference between the Emissions(kt) in Sub-Saharan Africa (developing only) and Emissions(kt) in Romania?
Offer a very short reply. 1.89e+05. In the year 1976, what is the difference between the Emissions(kt) in Albania and Emissions(kt) in Malaysia?
Make the answer very short. 1177.11. In the year 1976, what is the difference between the Emissions(kt) of Albania and Emissions(kt) of Romania?
Make the answer very short. -4.26e+04. In the year 1976, what is the difference between the Emissions(kt) in Malaysia and Emissions(kt) in Romania?
Keep it short and to the point. -4.38e+04. In the year 1977, what is the difference between the Emissions(kt) of Sub-Saharan Africa (developing only) and Emissions(kt) of Albania?
Ensure brevity in your answer.  2.37e+05. In the year 1977, what is the difference between the Emissions(kt) in Sub-Saharan Africa (developing only) and Emissions(kt) in Malaysia?
Give a very brief answer. 2.39e+05. In the year 1977, what is the difference between the Emissions(kt) of Sub-Saharan Africa (developing only) and Emissions(kt) of Romania?
Make the answer very short. 1.94e+05. In the year 1977, what is the difference between the Emissions(kt) of Albania and Emissions(kt) of Malaysia?
Provide a succinct answer. 1584.14. In the year 1977, what is the difference between the Emissions(kt) in Albania and Emissions(kt) in Romania?
Provide a succinct answer. -4.30e+04. In the year 1977, what is the difference between the Emissions(kt) in Malaysia and Emissions(kt) in Romania?
Give a very brief answer. -4.46e+04. In the year 1978, what is the difference between the Emissions(kt) in Sub-Saharan Africa (developing only) and Emissions(kt) in Albania?
Provide a succinct answer. 2.41e+05. In the year 1978, what is the difference between the Emissions(kt) in Sub-Saharan Africa (developing only) and Emissions(kt) in Malaysia?
Provide a succinct answer. 2.43e+05. In the year 1978, what is the difference between the Emissions(kt) in Sub-Saharan Africa (developing only) and Emissions(kt) in Romania?
Make the answer very short. 1.92e+05. In the year 1978, what is the difference between the Emissions(kt) of Albania and Emissions(kt) of Malaysia?
Offer a terse response. 2035.18. In the year 1978, what is the difference between the Emissions(kt) in Albania and Emissions(kt) in Romania?
Your answer should be very brief. -4.81e+04. In the year 1978, what is the difference between the Emissions(kt) of Malaysia and Emissions(kt) of Romania?
Your response must be concise. -5.01e+04. In the year 1979, what is the difference between the Emissions(kt) in Sub-Saharan Africa (developing only) and Emissions(kt) in Albania?
Make the answer very short. 2.66e+05. In the year 1979, what is the difference between the Emissions(kt) of Sub-Saharan Africa (developing only) and Emissions(kt) of Malaysia?
Your answer should be compact. 2.68e+05. In the year 1979, what is the difference between the Emissions(kt) in Sub-Saharan Africa (developing only) and Emissions(kt) in Romania?
Offer a terse response. 2.14e+05. In the year 1979, what is the difference between the Emissions(kt) of Albania and Emissions(kt) of Malaysia?
Give a very brief answer. 2548.57. In the year 1979, what is the difference between the Emissions(kt) of Albania and Emissions(kt) of Romania?
Provide a short and direct response. -5.14e+04. In the year 1979, what is the difference between the Emissions(kt) of Malaysia and Emissions(kt) of Romania?
Ensure brevity in your answer.  -5.39e+04. What is the ratio of the Emissions(kt) of Albania in 1972 to that in 1973?
Ensure brevity in your answer.  0.92. What is the ratio of the Emissions(kt) of Malaysia in 1972 to that in 1973?
Offer a very short reply. 0.26. What is the ratio of the Emissions(kt) in Romania in 1972 to that in 1973?
Offer a terse response. 0.89. What is the ratio of the Emissions(kt) of Sub-Saharan Africa (developing only) in 1972 to that in 1974?
Provide a short and direct response. 0.98. What is the ratio of the Emissions(kt) in Albania in 1972 to that in 1974?
Ensure brevity in your answer.  0.89. What is the ratio of the Emissions(kt) in Malaysia in 1972 to that in 1974?
Make the answer very short. 0.2. What is the ratio of the Emissions(kt) of Romania in 1972 to that in 1974?
Give a very brief answer. 0.85. What is the ratio of the Emissions(kt) in Sub-Saharan Africa (developing only) in 1972 to that in 1975?
Keep it short and to the point. 0.97. What is the ratio of the Emissions(kt) in Albania in 1972 to that in 1975?
Provide a short and direct response. 0.86. What is the ratio of the Emissions(kt) of Malaysia in 1972 to that in 1975?
Make the answer very short. 0.47. What is the ratio of the Emissions(kt) of Romania in 1972 to that in 1975?
Make the answer very short. 0.81. What is the ratio of the Emissions(kt) of Sub-Saharan Africa (developing only) in 1972 to that in 1976?
Offer a very short reply. 0.9. What is the ratio of the Emissions(kt) of Albania in 1972 to that in 1976?
Your answer should be very brief. 0.85. What is the ratio of the Emissions(kt) of Malaysia in 1972 to that in 1976?
Give a very brief answer. 0.35. What is the ratio of the Emissions(kt) of Romania in 1972 to that in 1976?
Your answer should be compact. 0.81. What is the ratio of the Emissions(kt) in Sub-Saharan Africa (developing only) in 1972 to that in 1977?
Offer a very short reply. 0.88. What is the ratio of the Emissions(kt) of Albania in 1972 to that in 1977?
Offer a very short reply. 0.64. What is the ratio of the Emissions(kt) of Malaysia in 1972 to that in 1977?
Your answer should be compact. 0.28. What is the ratio of the Emissions(kt) of Romania in 1972 to that in 1977?
Ensure brevity in your answer.  0.79. What is the ratio of the Emissions(kt) of Sub-Saharan Africa (developing only) in 1972 to that in 1978?
Make the answer very short. 0.86. What is the ratio of the Emissions(kt) in Albania in 1972 to that in 1978?
Your response must be concise. 0.51. What is the ratio of the Emissions(kt) in Malaysia in 1972 to that in 1978?
Your answer should be very brief. 0.36. What is the ratio of the Emissions(kt) in Romania in 1972 to that in 1978?
Offer a terse response. 0.71. What is the ratio of the Emissions(kt) of Sub-Saharan Africa (developing only) in 1972 to that in 1979?
Make the answer very short. 0.78. What is the ratio of the Emissions(kt) of Albania in 1972 to that in 1979?
Make the answer very short. 0.4. What is the ratio of the Emissions(kt) of Malaysia in 1972 to that in 1979?
Ensure brevity in your answer.  0.24. What is the ratio of the Emissions(kt) of Romania in 1972 to that in 1979?
Your response must be concise. 0.66. What is the ratio of the Emissions(kt) in Sub-Saharan Africa (developing only) in 1973 to that in 1974?
Offer a very short reply. 0.98. What is the ratio of the Emissions(kt) of Albania in 1973 to that in 1974?
Ensure brevity in your answer.  0.97. What is the ratio of the Emissions(kt) of Malaysia in 1973 to that in 1974?
Give a very brief answer. 0.8. What is the ratio of the Emissions(kt) in Romania in 1973 to that in 1974?
Provide a short and direct response. 0.96. What is the ratio of the Emissions(kt) of Sub-Saharan Africa (developing only) in 1973 to that in 1975?
Give a very brief answer. 0.97. What is the ratio of the Emissions(kt) of Albania in 1973 to that in 1975?
Provide a succinct answer. 0.93. What is the ratio of the Emissions(kt) in Malaysia in 1973 to that in 1975?
Keep it short and to the point. 1.84. What is the ratio of the Emissions(kt) of Romania in 1973 to that in 1975?
Provide a succinct answer. 0.91. What is the ratio of the Emissions(kt) in Sub-Saharan Africa (developing only) in 1973 to that in 1976?
Your answer should be compact. 0.9. What is the ratio of the Emissions(kt) of Albania in 1973 to that in 1976?
Your answer should be compact. 0.92. What is the ratio of the Emissions(kt) in Malaysia in 1973 to that in 1976?
Your response must be concise. 1.35. What is the ratio of the Emissions(kt) in Romania in 1973 to that in 1976?
Ensure brevity in your answer.  0.91. What is the ratio of the Emissions(kt) of Sub-Saharan Africa (developing only) in 1973 to that in 1977?
Your answer should be very brief. 0.88. What is the ratio of the Emissions(kt) of Albania in 1973 to that in 1977?
Keep it short and to the point. 0.69. What is the ratio of the Emissions(kt) in Malaysia in 1973 to that in 1977?
Provide a short and direct response. 1.09. What is the ratio of the Emissions(kt) of Romania in 1973 to that in 1977?
Give a very brief answer. 0.89. What is the ratio of the Emissions(kt) in Sub-Saharan Africa (developing only) in 1973 to that in 1978?
Provide a succinct answer. 0.87. What is the ratio of the Emissions(kt) in Albania in 1973 to that in 1978?
Your answer should be very brief. 0.55. What is the ratio of the Emissions(kt) in Romania in 1973 to that in 1978?
Your answer should be very brief. 0.8. What is the ratio of the Emissions(kt) of Sub-Saharan Africa (developing only) in 1973 to that in 1979?
Offer a terse response. 0.78. What is the ratio of the Emissions(kt) in Albania in 1973 to that in 1979?
Offer a very short reply. 0.44. What is the ratio of the Emissions(kt) of Malaysia in 1973 to that in 1979?
Provide a succinct answer. 0.95. What is the ratio of the Emissions(kt) in Romania in 1973 to that in 1979?
Keep it short and to the point. 0.74. What is the ratio of the Emissions(kt) of Sub-Saharan Africa (developing only) in 1974 to that in 1975?
Offer a very short reply. 0.98. What is the ratio of the Emissions(kt) of Albania in 1974 to that in 1975?
Provide a succinct answer. 0.96. What is the ratio of the Emissions(kt) of Malaysia in 1974 to that in 1975?
Provide a short and direct response. 2.32. What is the ratio of the Emissions(kt) in Romania in 1974 to that in 1975?
Offer a terse response. 0.95. What is the ratio of the Emissions(kt) of Sub-Saharan Africa (developing only) in 1974 to that in 1976?
Ensure brevity in your answer.  0.92. What is the ratio of the Emissions(kt) in Albania in 1974 to that in 1976?
Give a very brief answer. 0.95. What is the ratio of the Emissions(kt) of Malaysia in 1974 to that in 1976?
Your response must be concise. 1.69. What is the ratio of the Emissions(kt) in Romania in 1974 to that in 1976?
Provide a short and direct response. 0.95. What is the ratio of the Emissions(kt) in Sub-Saharan Africa (developing only) in 1974 to that in 1977?
Your answer should be very brief. 0.89. What is the ratio of the Emissions(kt) of Albania in 1974 to that in 1977?
Offer a very short reply. 0.71. What is the ratio of the Emissions(kt) in Malaysia in 1974 to that in 1977?
Offer a terse response. 1.38. What is the ratio of the Emissions(kt) of Romania in 1974 to that in 1977?
Give a very brief answer. 0.93. What is the ratio of the Emissions(kt) of Sub-Saharan Africa (developing only) in 1974 to that in 1978?
Offer a terse response. 0.88. What is the ratio of the Emissions(kt) in Albania in 1974 to that in 1978?
Provide a short and direct response. 0.57. What is the ratio of the Emissions(kt) in Malaysia in 1974 to that in 1978?
Keep it short and to the point. 1.76. What is the ratio of the Emissions(kt) in Romania in 1974 to that in 1978?
Make the answer very short. 0.83. What is the ratio of the Emissions(kt) in Sub-Saharan Africa (developing only) in 1974 to that in 1979?
Provide a succinct answer. 0.79. What is the ratio of the Emissions(kt) in Albania in 1974 to that in 1979?
Ensure brevity in your answer.  0.45. What is the ratio of the Emissions(kt) of Malaysia in 1974 to that in 1979?
Your response must be concise. 1.19. What is the ratio of the Emissions(kt) in Romania in 1974 to that in 1979?
Your answer should be compact. 0.77. What is the ratio of the Emissions(kt) of Sub-Saharan Africa (developing only) in 1975 to that in 1976?
Keep it short and to the point. 0.93. What is the ratio of the Emissions(kt) of Albania in 1975 to that in 1976?
Your response must be concise. 0.99. What is the ratio of the Emissions(kt) of Malaysia in 1975 to that in 1976?
Provide a succinct answer. 0.73. What is the ratio of the Emissions(kt) of Romania in 1975 to that in 1976?
Offer a terse response. 1. What is the ratio of the Emissions(kt) in Sub-Saharan Africa (developing only) in 1975 to that in 1977?
Your answer should be very brief. 0.91. What is the ratio of the Emissions(kt) of Albania in 1975 to that in 1977?
Give a very brief answer. 0.74. What is the ratio of the Emissions(kt) in Malaysia in 1975 to that in 1977?
Make the answer very short. 0.59. What is the ratio of the Emissions(kt) in Romania in 1975 to that in 1977?
Provide a succinct answer. 0.98. What is the ratio of the Emissions(kt) of Sub-Saharan Africa (developing only) in 1975 to that in 1978?
Keep it short and to the point. 0.9. What is the ratio of the Emissions(kt) of Albania in 1975 to that in 1978?
Provide a succinct answer. 0.59. What is the ratio of the Emissions(kt) of Malaysia in 1975 to that in 1978?
Keep it short and to the point. 0.76. What is the ratio of the Emissions(kt) in Romania in 1975 to that in 1978?
Offer a terse response. 0.88. What is the ratio of the Emissions(kt) in Sub-Saharan Africa (developing only) in 1975 to that in 1979?
Give a very brief answer. 0.81. What is the ratio of the Emissions(kt) in Albania in 1975 to that in 1979?
Keep it short and to the point. 0.47. What is the ratio of the Emissions(kt) in Malaysia in 1975 to that in 1979?
Offer a terse response. 0.51. What is the ratio of the Emissions(kt) of Romania in 1975 to that in 1979?
Your answer should be very brief. 0.81. What is the ratio of the Emissions(kt) in Sub-Saharan Africa (developing only) in 1976 to that in 1977?
Provide a succinct answer. 0.97. What is the ratio of the Emissions(kt) of Albania in 1976 to that in 1977?
Offer a terse response. 0.75. What is the ratio of the Emissions(kt) of Malaysia in 1976 to that in 1977?
Your answer should be very brief. 0.81. What is the ratio of the Emissions(kt) of Romania in 1976 to that in 1977?
Offer a terse response. 0.98. What is the ratio of the Emissions(kt) of Sub-Saharan Africa (developing only) in 1976 to that in 1978?
Keep it short and to the point. 0.96. What is the ratio of the Emissions(kt) in Albania in 1976 to that in 1978?
Ensure brevity in your answer.  0.6. What is the ratio of the Emissions(kt) in Romania in 1976 to that in 1978?
Offer a terse response. 0.87. What is the ratio of the Emissions(kt) in Sub-Saharan Africa (developing only) in 1976 to that in 1979?
Offer a terse response. 0.87. What is the ratio of the Emissions(kt) of Albania in 1976 to that in 1979?
Your response must be concise. 0.47. What is the ratio of the Emissions(kt) of Malaysia in 1976 to that in 1979?
Ensure brevity in your answer.  0.7. What is the ratio of the Emissions(kt) in Romania in 1976 to that in 1979?
Offer a very short reply. 0.81. What is the ratio of the Emissions(kt) in Sub-Saharan Africa (developing only) in 1977 to that in 1978?
Provide a short and direct response. 0.99. What is the ratio of the Emissions(kt) of Albania in 1977 to that in 1978?
Your answer should be compact. 0.8. What is the ratio of the Emissions(kt) of Malaysia in 1977 to that in 1978?
Make the answer very short. 1.28. What is the ratio of the Emissions(kt) of Romania in 1977 to that in 1978?
Give a very brief answer. 0.89. What is the ratio of the Emissions(kt) in Sub-Saharan Africa (developing only) in 1977 to that in 1979?
Your answer should be very brief. 0.89. What is the ratio of the Emissions(kt) in Albania in 1977 to that in 1979?
Provide a succinct answer. 0.63. What is the ratio of the Emissions(kt) in Malaysia in 1977 to that in 1979?
Offer a terse response. 0.86. What is the ratio of the Emissions(kt) in Romania in 1977 to that in 1979?
Your response must be concise. 0.83. What is the ratio of the Emissions(kt) of Sub-Saharan Africa (developing only) in 1978 to that in 1979?
Your response must be concise. 0.9. What is the ratio of the Emissions(kt) of Albania in 1978 to that in 1979?
Offer a very short reply. 0.79. What is the ratio of the Emissions(kt) of Malaysia in 1978 to that in 1979?
Offer a terse response. 0.68. What is the ratio of the Emissions(kt) in Romania in 1978 to that in 1979?
Ensure brevity in your answer.  0.93. What is the difference between the highest and the second highest Emissions(kt) of Sub-Saharan Africa (developing only)?
Give a very brief answer. 2.58e+04. What is the difference between the highest and the second highest Emissions(kt) of Albania?
Offer a very short reply. 557.38. What is the difference between the highest and the second highest Emissions(kt) of Malaysia?
Keep it short and to the point. 25.67. What is the difference between the highest and the second highest Emissions(kt) in Romania?
Your response must be concise. 3810.01. What is the difference between the highest and the lowest Emissions(kt) of Sub-Saharan Africa (developing only)?
Provide a short and direct response. 5.87e+04. What is the difference between the highest and the lowest Emissions(kt) of Albania?
Offer a terse response. 1602.48. What is the difference between the highest and the lowest Emissions(kt) in Malaysia?
Offer a very short reply. 128.34. What is the difference between the highest and the lowest Emissions(kt) in Romania?
Ensure brevity in your answer.  1.86e+04. 